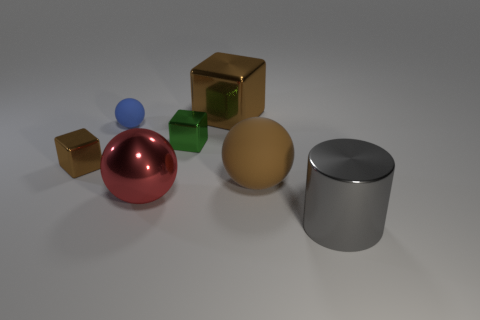Subtract all small brown cubes. How many cubes are left? 2 Add 2 small cyan rubber blocks. How many objects exist? 9 Subtract all purple spheres. How many red cylinders are left? 0 Subtract all green cubes. How many cubes are left? 2 Subtract 3 spheres. How many spheres are left? 0 Subtract all blue cubes. Subtract all cyan cylinders. How many cubes are left? 3 Add 7 tiny brown things. How many tiny brown things are left? 8 Add 4 gray cylinders. How many gray cylinders exist? 5 Subtract 0 red blocks. How many objects are left? 7 Subtract all balls. How many objects are left? 4 